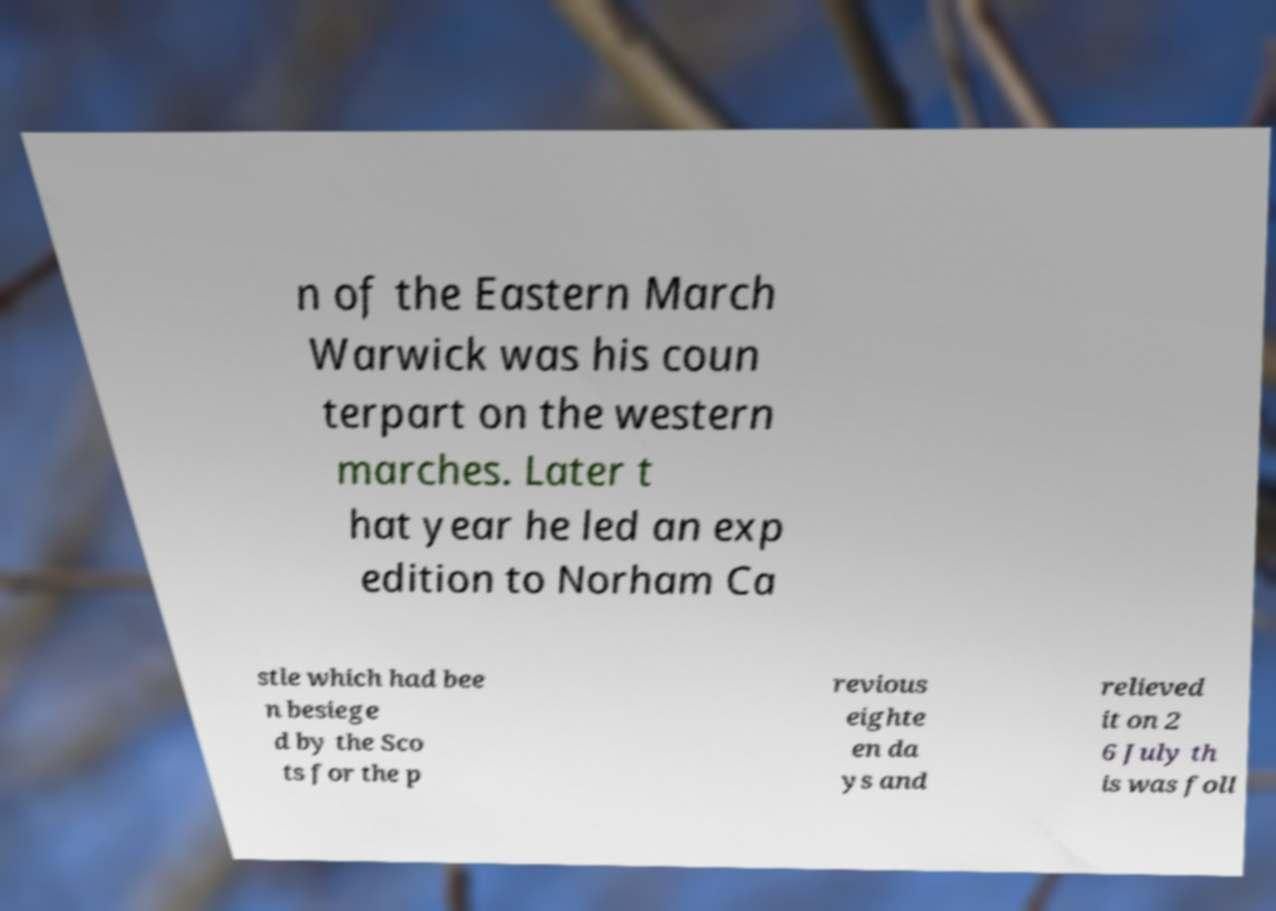Can you accurately transcribe the text from the provided image for me? n of the Eastern March Warwick was his coun terpart on the western marches. Later t hat year he led an exp edition to Norham Ca stle which had bee n besiege d by the Sco ts for the p revious eighte en da ys and relieved it on 2 6 July th is was foll 